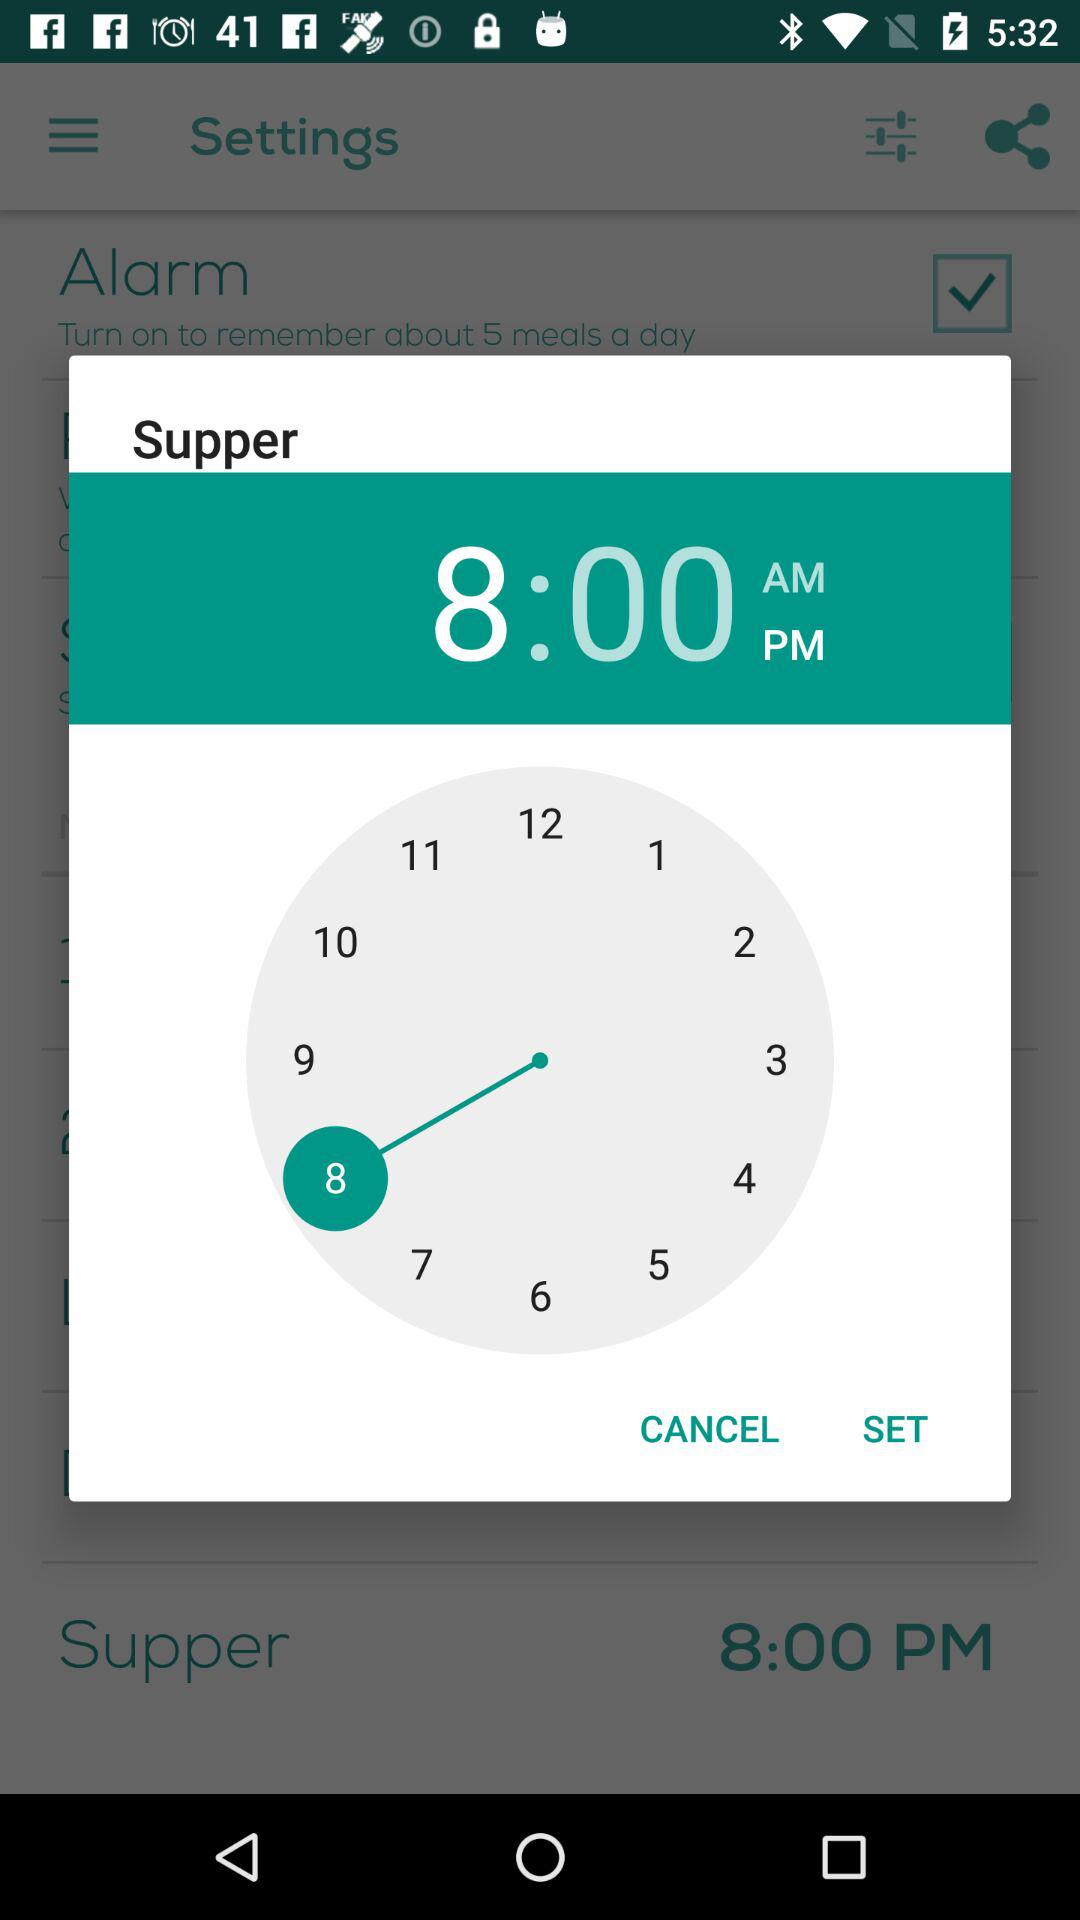How many numbers are on the clock?
Answer the question using a single word or phrase. 12 